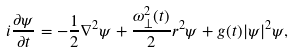Convert formula to latex. <formula><loc_0><loc_0><loc_500><loc_500>i \frac { \partial \psi } { \partial t } = - \frac { 1 } { 2 } \nabla ^ { 2 } \psi + \frac { \omega _ { \perp } ^ { 2 } ( t ) } { 2 } r ^ { 2 } \psi + g ( t ) | \psi | ^ { 2 } \psi ,</formula> 